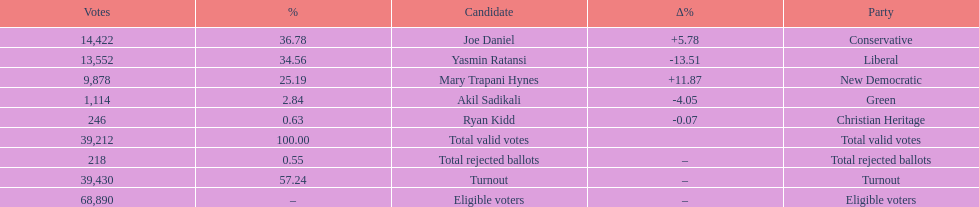Which candidate had the most votes? Joe Daniel. 